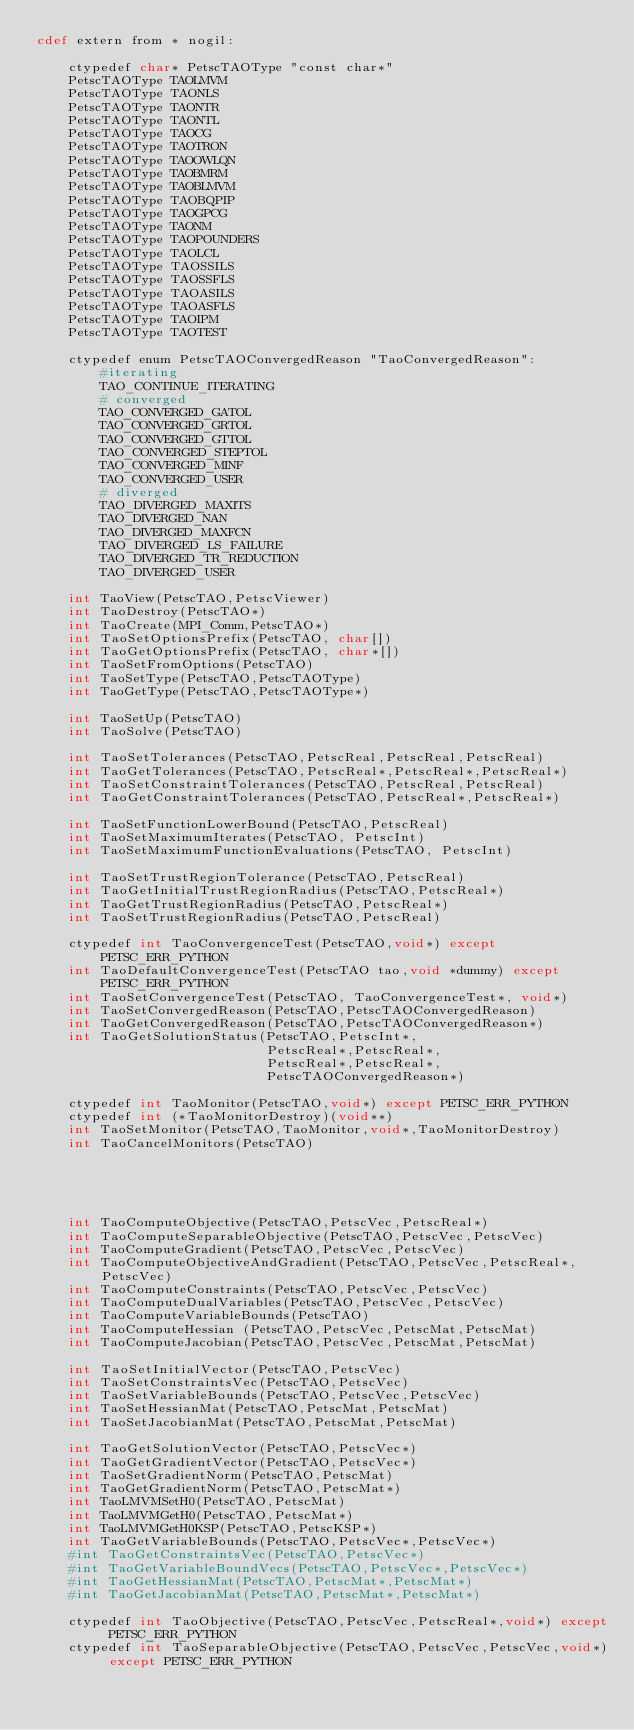Convert code to text. <code><loc_0><loc_0><loc_500><loc_500><_Cython_>cdef extern from * nogil:

    ctypedef char* PetscTAOType "const char*"
    PetscTAOType TAOLMVM
    PetscTAOType TAONLS
    PetscTAOType TAONTR
    PetscTAOType TAONTL
    PetscTAOType TAOCG
    PetscTAOType TAOTRON
    PetscTAOType TAOOWLQN
    PetscTAOType TAOBMRM
    PetscTAOType TAOBLMVM
    PetscTAOType TAOBQPIP
    PetscTAOType TAOGPCG
    PetscTAOType TAONM
    PetscTAOType TAOPOUNDERS
    PetscTAOType TAOLCL
    PetscTAOType TAOSSILS
    PetscTAOType TAOSSFLS
    PetscTAOType TAOASILS
    PetscTAOType TAOASFLS
    PetscTAOType TAOIPM
    PetscTAOType TAOTEST

    ctypedef enum PetscTAOConvergedReason "TaoConvergedReason":
        #iterating
        TAO_CONTINUE_ITERATING
        # converged
        TAO_CONVERGED_GATOL
        TAO_CONVERGED_GRTOL
        TAO_CONVERGED_GTTOL
        TAO_CONVERGED_STEPTOL
        TAO_CONVERGED_MINF
        TAO_CONVERGED_USER
        # diverged
        TAO_DIVERGED_MAXITS
        TAO_DIVERGED_NAN
        TAO_DIVERGED_MAXFCN
        TAO_DIVERGED_LS_FAILURE
        TAO_DIVERGED_TR_REDUCTION
        TAO_DIVERGED_USER

    int TaoView(PetscTAO,PetscViewer)
    int TaoDestroy(PetscTAO*)
    int TaoCreate(MPI_Comm,PetscTAO*)
    int TaoSetOptionsPrefix(PetscTAO, char[])
    int TaoGetOptionsPrefix(PetscTAO, char*[])
    int TaoSetFromOptions(PetscTAO)
    int TaoSetType(PetscTAO,PetscTAOType)
    int TaoGetType(PetscTAO,PetscTAOType*)

    int TaoSetUp(PetscTAO)
    int TaoSolve(PetscTAO)

    int TaoSetTolerances(PetscTAO,PetscReal,PetscReal,PetscReal)
    int TaoGetTolerances(PetscTAO,PetscReal*,PetscReal*,PetscReal*)
    int TaoSetConstraintTolerances(PetscTAO,PetscReal,PetscReal)
    int TaoGetConstraintTolerances(PetscTAO,PetscReal*,PetscReal*)

    int TaoSetFunctionLowerBound(PetscTAO,PetscReal)
    int TaoSetMaximumIterates(PetscTAO, PetscInt)
    int TaoSetMaximumFunctionEvaluations(PetscTAO, PetscInt)

    int TaoSetTrustRegionTolerance(PetscTAO,PetscReal)
    int TaoGetInitialTrustRegionRadius(PetscTAO,PetscReal*)
    int TaoGetTrustRegionRadius(PetscTAO,PetscReal*)
    int TaoSetTrustRegionRadius(PetscTAO,PetscReal)

    ctypedef int TaoConvergenceTest(PetscTAO,void*) except PETSC_ERR_PYTHON
    int TaoDefaultConvergenceTest(PetscTAO tao,void *dummy) except PETSC_ERR_PYTHON
    int TaoSetConvergenceTest(PetscTAO, TaoConvergenceTest*, void*)
    int TaoSetConvergedReason(PetscTAO,PetscTAOConvergedReason)
    int TaoGetConvergedReason(PetscTAO,PetscTAOConvergedReason*)
    int TaoGetSolutionStatus(PetscTAO,PetscInt*,
                             PetscReal*,PetscReal*,
                             PetscReal*,PetscReal*,
                             PetscTAOConvergedReason*)

    ctypedef int TaoMonitor(PetscTAO,void*) except PETSC_ERR_PYTHON
    ctypedef int (*TaoMonitorDestroy)(void**)
    int TaoSetMonitor(PetscTAO,TaoMonitor,void*,TaoMonitorDestroy)
    int TaoCancelMonitors(PetscTAO)





    int TaoComputeObjective(PetscTAO,PetscVec,PetscReal*)
    int TaoComputeSeparableObjective(PetscTAO,PetscVec,PetscVec)
    int TaoComputeGradient(PetscTAO,PetscVec,PetscVec)
    int TaoComputeObjectiveAndGradient(PetscTAO,PetscVec,PetscReal*,PetscVec)
    int TaoComputeConstraints(PetscTAO,PetscVec,PetscVec)
    int TaoComputeDualVariables(PetscTAO,PetscVec,PetscVec)
    int TaoComputeVariableBounds(PetscTAO)
    int TaoComputeHessian (PetscTAO,PetscVec,PetscMat,PetscMat)
    int TaoComputeJacobian(PetscTAO,PetscVec,PetscMat,PetscMat)

    int TaoSetInitialVector(PetscTAO,PetscVec)
    int TaoSetConstraintsVec(PetscTAO,PetscVec)
    int TaoSetVariableBounds(PetscTAO,PetscVec,PetscVec)
    int TaoSetHessianMat(PetscTAO,PetscMat,PetscMat)
    int TaoSetJacobianMat(PetscTAO,PetscMat,PetscMat)

    int TaoGetSolutionVector(PetscTAO,PetscVec*)
    int TaoGetGradientVector(PetscTAO,PetscVec*)
    int TaoSetGradientNorm(PetscTAO,PetscMat)
    int TaoGetGradientNorm(PetscTAO,PetscMat*)
    int TaoLMVMSetH0(PetscTAO,PetscMat)
    int TaoLMVMGetH0(PetscTAO,PetscMat*)
    int TaoLMVMGetH0KSP(PetscTAO,PetscKSP*)
    int TaoGetVariableBounds(PetscTAO,PetscVec*,PetscVec*)
    #int TaoGetConstraintsVec(PetscTAO,PetscVec*)
    #int TaoGetVariableBoundVecs(PetscTAO,PetscVec*,PetscVec*)
    #int TaoGetHessianMat(PetscTAO,PetscMat*,PetscMat*)
    #int TaoGetJacobianMat(PetscTAO,PetscMat*,PetscMat*)

    ctypedef int TaoObjective(PetscTAO,PetscVec,PetscReal*,void*) except PETSC_ERR_PYTHON
    ctypedef int TaoSeparableObjective(PetscTAO,PetscVec,PetscVec,void*) except PETSC_ERR_PYTHON</code> 